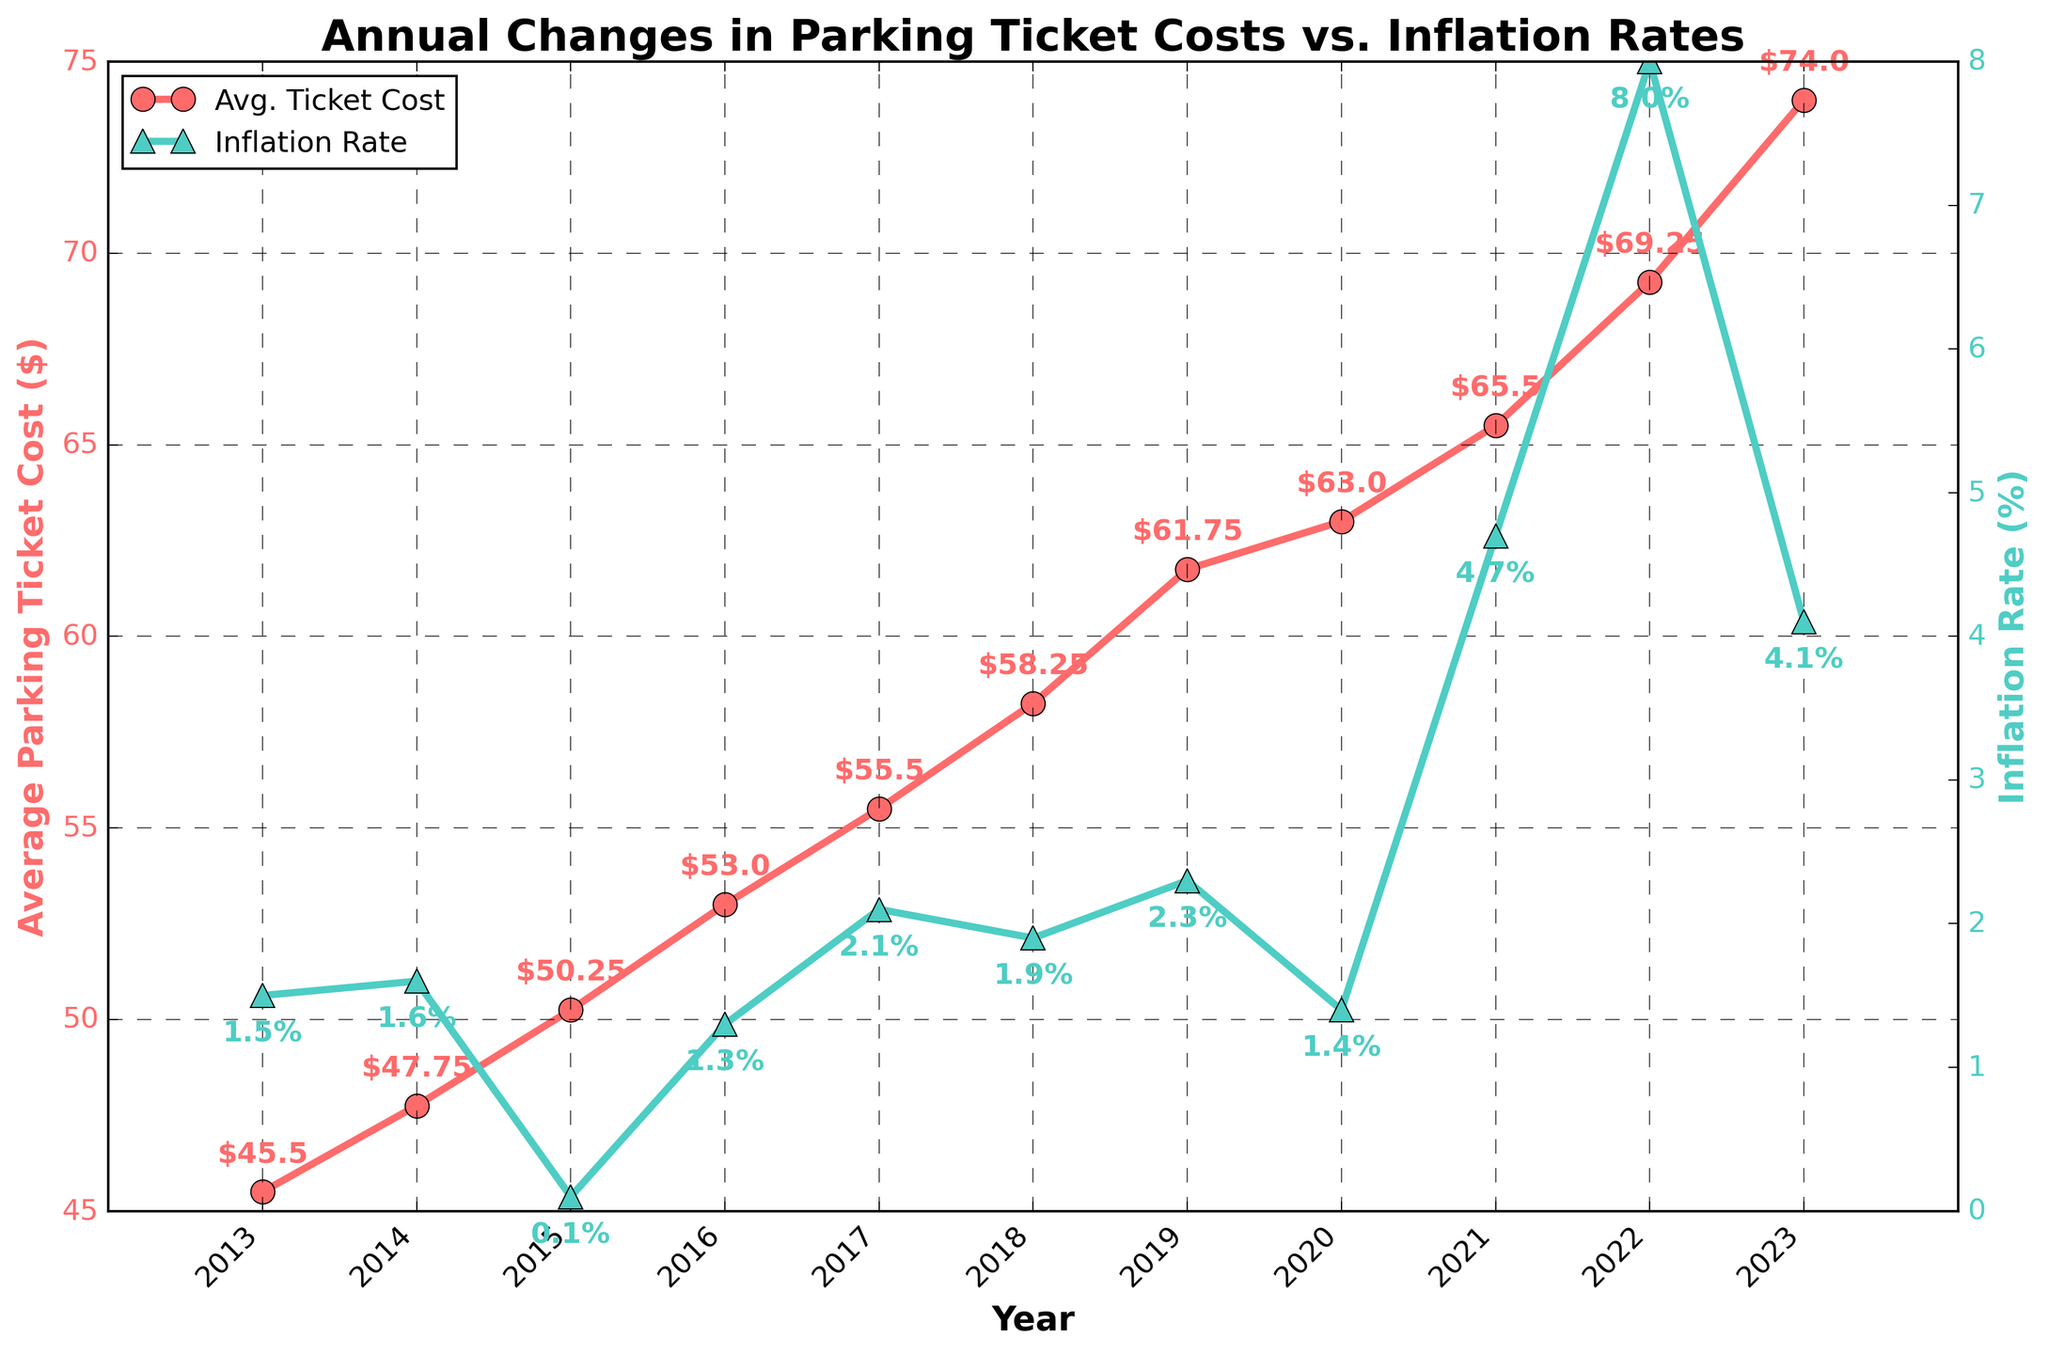What's the trend in the average cost of parking tickets over the years? The average cost of parking tickets shows a consistent upward trend from 2013 to 2023. We observe the ticket costs increasing each year.
Answer: Increasing How does the change in ticket costs compare to the change in inflation rates in 2020? In 2020, the ticket costs increased from $61.75 to $63.00, showing a slight increase, while the inflation rate decreased from 2.3% in 2019 to 1.4% in 2020.
Answer: Ticket costs increase more than inflation rates What's the difference between the average parking ticket cost in 2013 and 2023? The cost in 2013 was $45.50 and in 2023 it is $74.00. The difference is $74.00 - $45.50 = $28.50.
Answer: $28.50 In which year did the inflation rate peak, and what was the average parking ticket cost in that year? The inflation rate peaked in 2022 at 8.0%. The average parking ticket cost in that year was $69.25.
Answer: 2022, $69.25 Compare the trend of inflation rates with ticket costs from 2016 to 2018. What do you observe? From 2016 to 2018, the ticket costs increased from $53.00 to $58.25, and the inflation rates fluctuated: increasing from 1.3% in 2016 to 2.1% in 2017, then slightly decreasing to 1.9% in 2018.
Answer: Costs consistently increased, inflation fluctuated What is the average increase in parking ticket costs per year from 2013 to 2023? Subtract the initial cost in 2013 from the final cost in 2023, then divide by the number of years: ($74.00 - $45.50) / (2023 - 2013) = $28.50 / 10 = $2.85 per year.
Answer: $2.85 per year Which year experienced the lowest inflation rate, and what was the ticket cost then? The lowest inflation rate was in 2015 at 0.1%. The ticket cost in that year was $50.25.
Answer: 2015, $50.25 How much did the average parking ticket cost change from 2021 to 2022 compared to the inflation rate change? The ticket cost increased from $65.50 in 2021 to $69.25 in 2022, a change of $69.25 - $65.50 = $3.75. The inflation rate increased from 4.7% to 8.0%, a change of 8.0% - 4.7% = 3.3%.
Answer: Ticket cost increased by $3.75, inflation rate by 3.3% What is the cumulative difference in inflation rates from 2013 to 2023? Add up the differences in inflation rates year over year: (1.6 - 1.5) + (0.1 - 1.6) + (1.3 - 0.1) + (2.1 - 1.3) + (1.9 - 2.1) + (2.3 - 1.9) + (1.4 - 2.3) + (4.7 - 1.4) + (8.0 - 4.7) + (4.1 - 8.0) = 7.2%.
Answer: 7.2% What visual changes occur in the annotations for the parking ticket costs and inflation rates across the years? The annotations for parking ticket costs are consistent in red and positioned above the line, while inflation rate annotations are marked in green and below the line, clearly indicating their values at each data point.
Answer: Red above, green below 